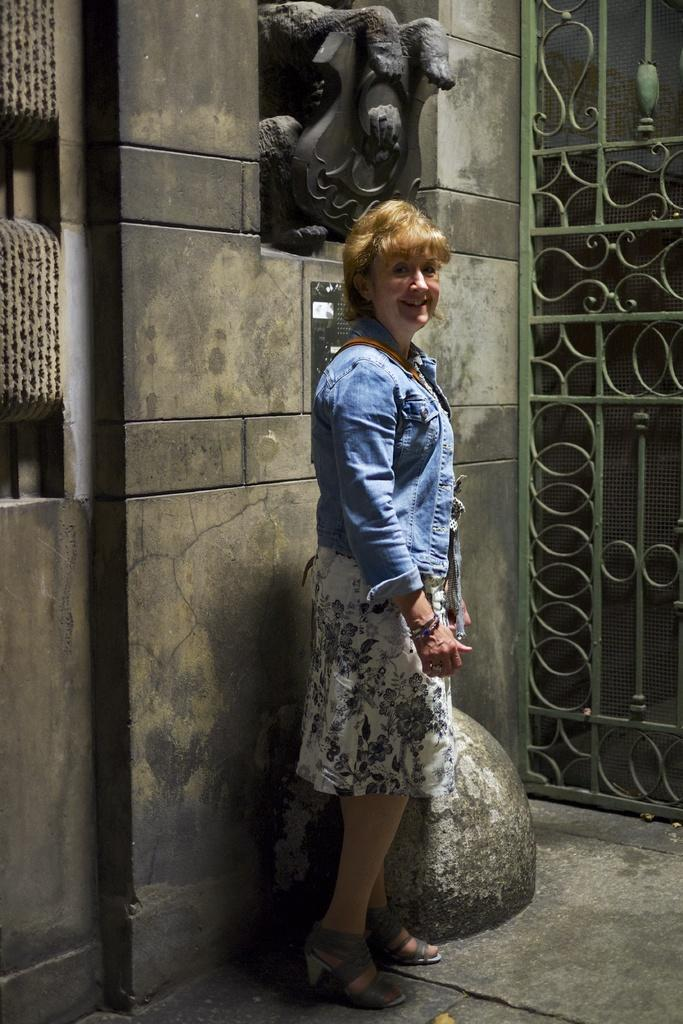What is the main subject of the image? There is a person standing in the image. What can be seen behind the person? There is a wall behind the person. Are there any decorative elements on the wall? Yes, there is a sculpture on the wall. What is located towards the right side of the image? There is a grill truncated towards the right of the image. How many needles are visible in the image? There are no needles present in the image. Can you describe the person's ability to jump in the image? The person is standing still in the image, so there is no indication of their ability to jump. 